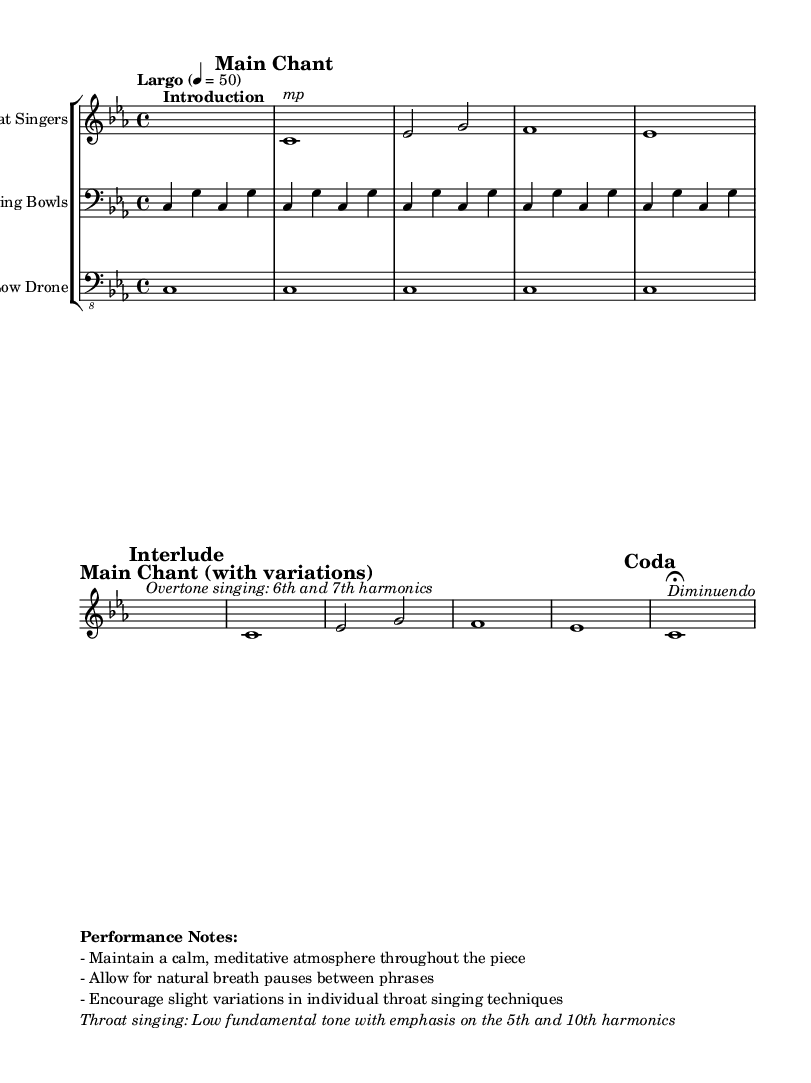What is the key signature of this music? The key signature is indicated by the symbol that appears at the beginning of the staff. In this case, there are three flats, which correspond to E♭ major or its relative minor, C minor.
Answer: C minor What is the time signature of this music? The time signature is marked at the beginning of the staff. It shows that there are four beats per measure, which is represented as 4/4.
Answer: 4/4 What is the tempo marking of this piece? The tempo is indicated above the staff with the Italian term "Largo," which typically means a slow pace, combined with the metronomic marking of 50 beats per minute.
Answer: Largo How many sections are there in the music? The music is divided into clearly marked sections: Introduction, Main Chant, Interlude, Main Chant (with variations), and Coda. Counting these gives a total of five sections.
Answer: 5 What type of instruments are indicated in the score? The score lists throat singers, singing bowls, and a low drone, each assigned to their own staff. This information can be found at the beginning of each staff indicating the instruments used in the performance.
Answer: Throat Singers, Singing Bowls, Low Drone What is the performance note regarding throat singing? The performance notes specify that the throat singing should feature a low fundamental tone with emphasis on the 5th and 10th harmonics. This indicates specific vocal techniques used during the performance.
Answer: Low fundamental tone with emphasis on the 5th and 10th harmonics What phrase describes the dynamics in the Coda section? The Coda section indicates a "Diminuendo," which suggests that the music should gradually decrease in volume as it progresses to the end. This dynamic marking is labeled in italics within the music.
Answer: Diminuendo 